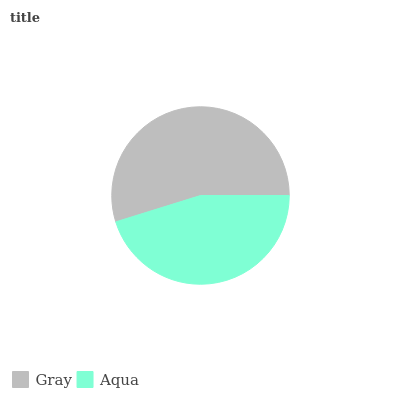Is Aqua the minimum?
Answer yes or no. Yes. Is Gray the maximum?
Answer yes or no. Yes. Is Aqua the maximum?
Answer yes or no. No. Is Gray greater than Aqua?
Answer yes or no. Yes. Is Aqua less than Gray?
Answer yes or no. Yes. Is Aqua greater than Gray?
Answer yes or no. No. Is Gray less than Aqua?
Answer yes or no. No. Is Gray the high median?
Answer yes or no. Yes. Is Aqua the low median?
Answer yes or no. Yes. Is Aqua the high median?
Answer yes or no. No. Is Gray the low median?
Answer yes or no. No. 